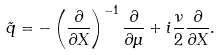Convert formula to latex. <formula><loc_0><loc_0><loc_500><loc_500>\tilde { q } = - \left ( \frac { \partial } { \partial X } \right ) ^ { - 1 } \frac { \partial } { \partial \mu } + i \frac { \nu } { 2 } \frac { \partial } { \partial X } .</formula> 